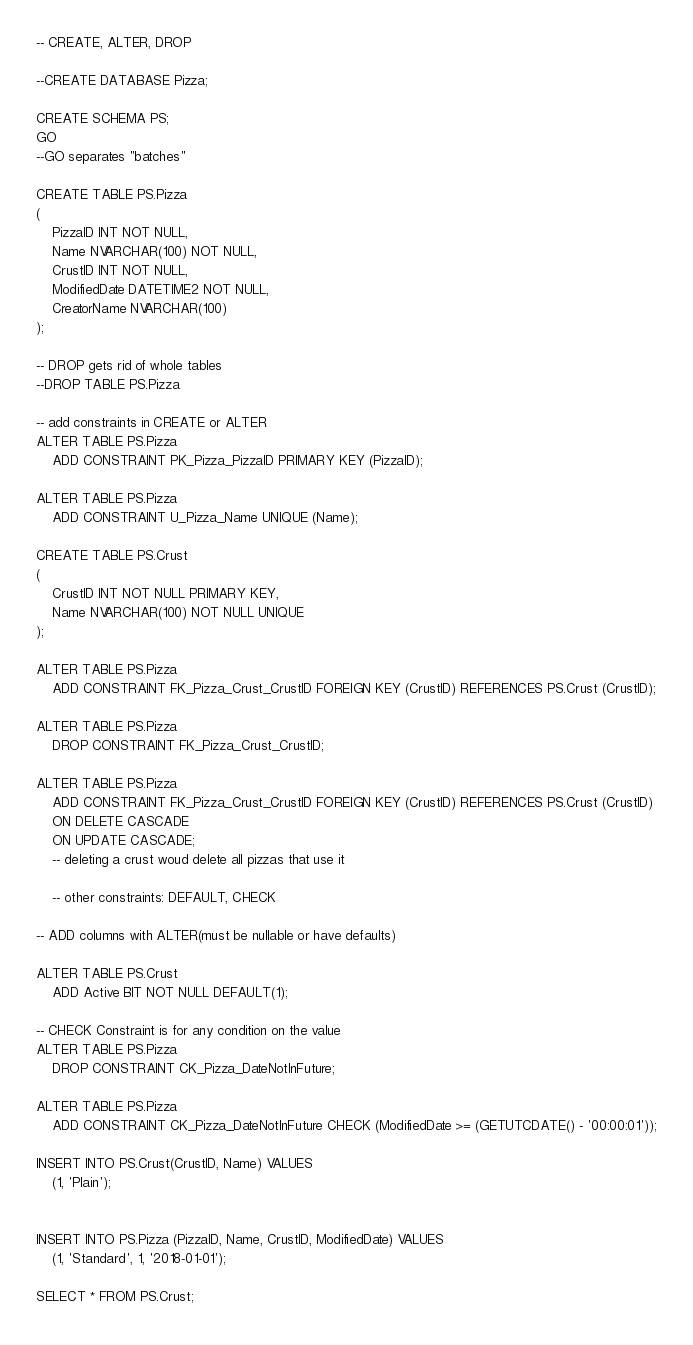Convert code to text. <code><loc_0><loc_0><loc_500><loc_500><_SQL_>-- CREATE, ALTER, DROP

--CREATE DATABASE Pizza;

CREATE SCHEMA PS;
GO
--GO separates "batches"

CREATE TABLE PS.Pizza
(
	PizzaID INT NOT NULL,
	Name NVARCHAR(100) NOT NULL,
	CrustID INT NOT NULL,
	ModifiedDate DATETIME2 NOT NULL,
	CreatorName NVARCHAR(100) 
);

-- DROP gets rid of whole tables
--DROP TABLE PS.Pizza

-- add constraints in CREATE or ALTER
ALTER TABLE PS.Pizza
	ADD CONSTRAINT PK_Pizza_PizzaID PRIMARY KEY (PizzaID);

ALTER TABLE PS.Pizza
	ADD CONSTRAINT U_Pizza_Name UNIQUE (Name);

CREATE TABLE PS.Crust
(
	CrustID INT NOT NULL PRIMARY KEY,
	Name NVARCHAR(100) NOT NULL UNIQUE
);

ALTER TABLE PS.Pizza
	ADD CONSTRAINT FK_Pizza_Crust_CrustID FOREIGN KEY (CrustID) REFERENCES PS.Crust (CrustID);

ALTER TABLE PS.Pizza
	DROP CONSTRAINT FK_Pizza_Crust_CrustID;

ALTER TABLE PS.Pizza
	ADD CONSTRAINT FK_Pizza_Crust_CrustID FOREIGN KEY (CrustID) REFERENCES PS.Crust (CrustID)
	ON DELETE CASCADE
	ON UPDATE CASCADE;
	-- deleting a crust woud delete all pizzas that use it

	-- other constraints: DEFAULT, CHECK
	
-- ADD columns with ALTER(must be nullable or have defaults)

ALTER TABLE PS.Crust
	ADD Active BIT NOT NULL DEFAULT(1);
	
-- CHECK Constraint is for any condition on the value
ALTER TABLE PS.Pizza
	DROP CONSTRAINT CK_Pizza_DateNotInFuture;

ALTER TABLE PS.Pizza
	ADD CONSTRAINT CK_Pizza_DateNotInFuture CHECK (ModifiedDate >= (GETUTCDATE() - '00:00:01'));

INSERT INTO PS.Crust(CrustID, Name) VALUES
	(1, 'Plain');


INSERT INTO PS.Pizza (PizzaID, Name, CrustID, ModifiedDate) VALUES
	(1, 'Standard', 1, '2018-01-01');

SELECT * FROM PS.Crust;
</code> 